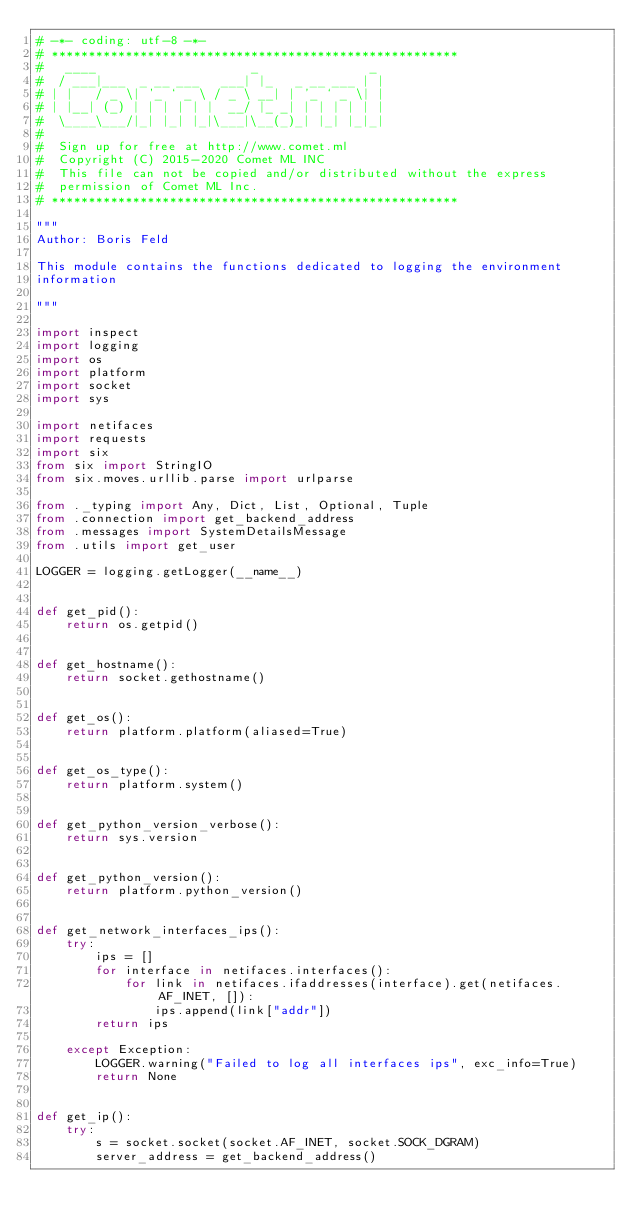Convert code to text. <code><loc_0><loc_0><loc_500><loc_500><_Python_># -*- coding: utf-8 -*-
# *******************************************************
#   ____                     _               _
#  / ___|___  _ __ ___   ___| |_   _ __ ___ | |
# | |   / _ \| '_ ` _ \ / _ \ __| | '_ ` _ \| |
# | |__| (_) | | | | | |  __/ |_ _| | | | | | |
#  \____\___/|_| |_| |_|\___|\__(_)_| |_| |_|_|
#
#  Sign up for free at http://www.comet.ml
#  Copyright (C) 2015-2020 Comet ML INC
#  This file can not be copied and/or distributed without the express
#  permission of Comet ML Inc.
# *******************************************************

"""
Author: Boris Feld

This module contains the functions dedicated to logging the environment
information

"""

import inspect
import logging
import os
import platform
import socket
import sys

import netifaces
import requests
import six
from six import StringIO
from six.moves.urllib.parse import urlparse

from ._typing import Any, Dict, List, Optional, Tuple
from .connection import get_backend_address
from .messages import SystemDetailsMessage
from .utils import get_user

LOGGER = logging.getLogger(__name__)


def get_pid():
    return os.getpid()


def get_hostname():
    return socket.gethostname()


def get_os():
    return platform.platform(aliased=True)


def get_os_type():
    return platform.system()


def get_python_version_verbose():
    return sys.version


def get_python_version():
    return platform.python_version()


def get_network_interfaces_ips():
    try:
        ips = []
        for interface in netifaces.interfaces():
            for link in netifaces.ifaddresses(interface).get(netifaces.AF_INET, []):
                ips.append(link["addr"])
        return ips

    except Exception:
        LOGGER.warning("Failed to log all interfaces ips", exc_info=True)
        return None


def get_ip():
    try:
        s = socket.socket(socket.AF_INET, socket.SOCK_DGRAM)
        server_address = get_backend_address()</code> 